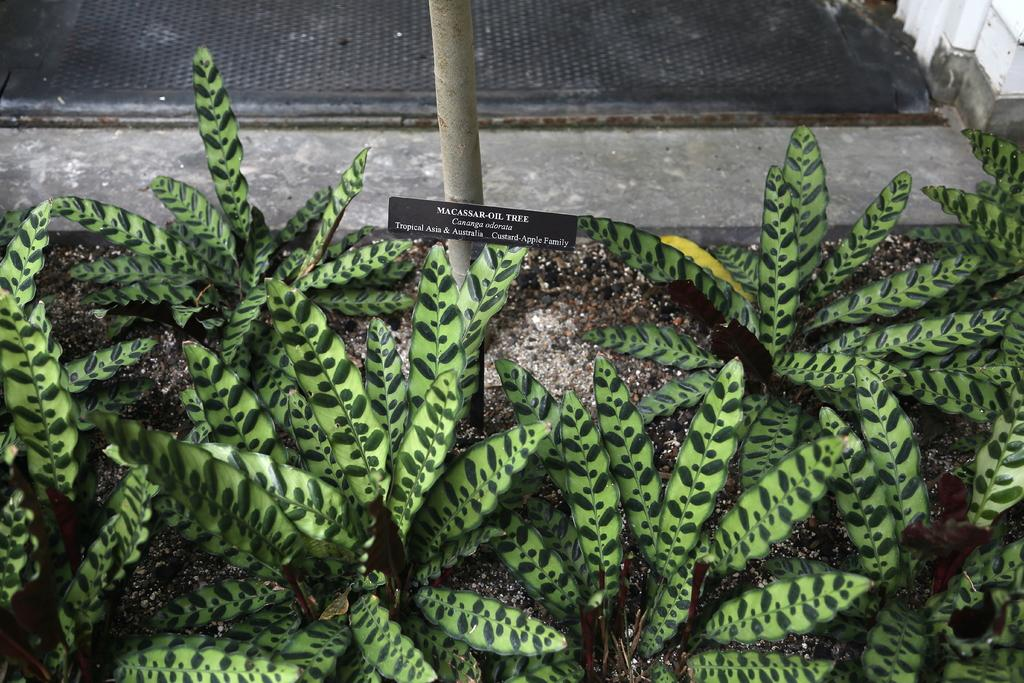What type of vegetation is at the bottom of the image? There are plants at the bottom of the image. What type of flooring is at the top of the image? There is a carpet at the top of the image. What is the experience of the plants in the image? The image does not convey any experience of the plants; it only shows their presence in the image. What is the plot of the carpet in the image? The image does not have a plot, as it is a still image and not a narrative. 